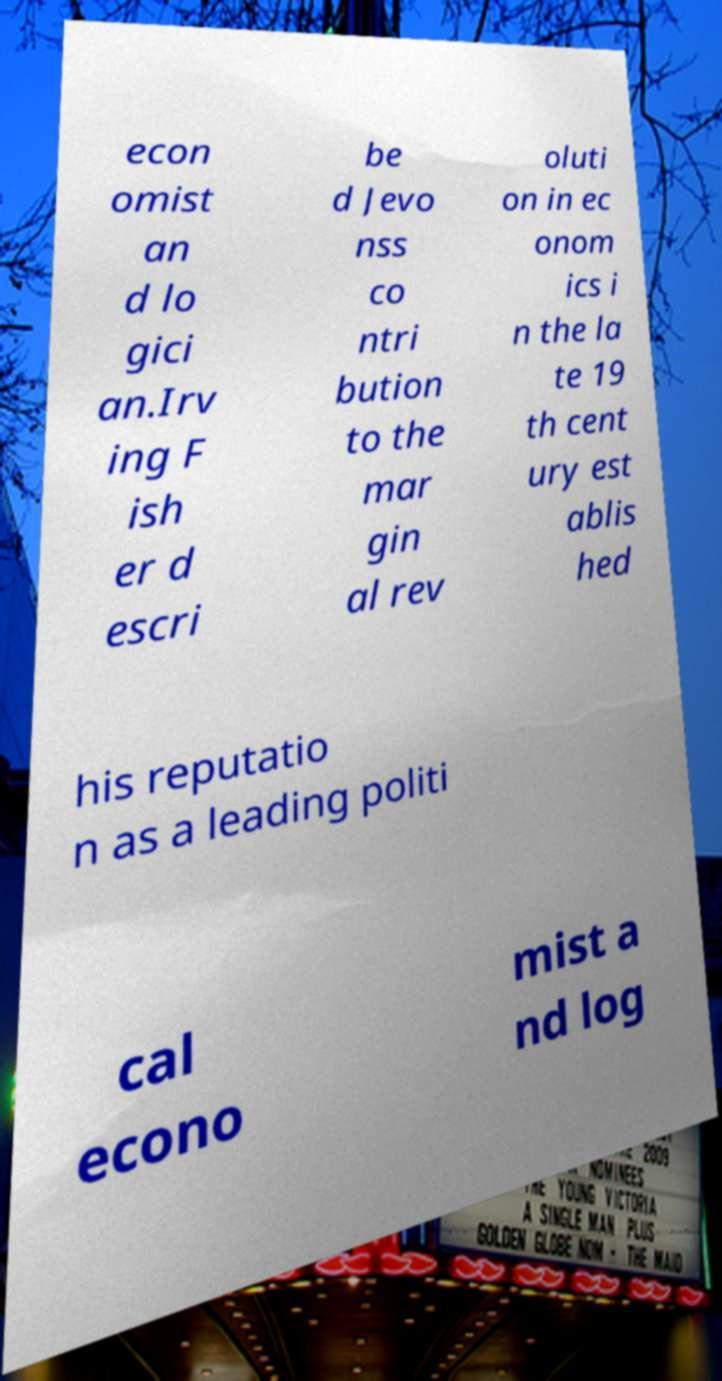There's text embedded in this image that I need extracted. Can you transcribe it verbatim? econ omist an d lo gici an.Irv ing F ish er d escri be d Jevo nss co ntri bution to the mar gin al rev oluti on in ec onom ics i n the la te 19 th cent ury est ablis hed his reputatio n as a leading politi cal econo mist a nd log 